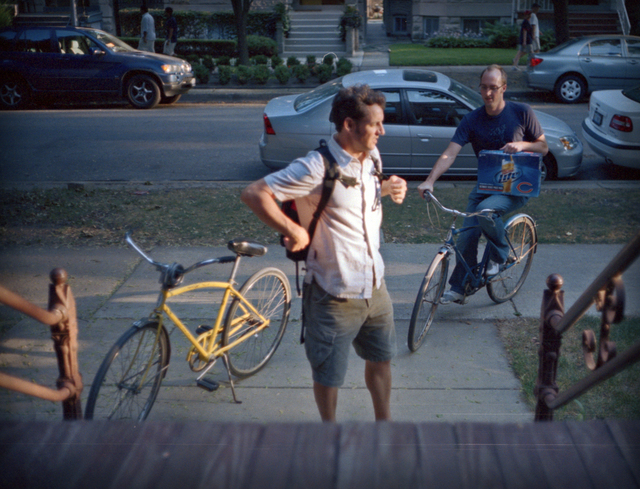What time of day does this scene depict, and what does that suggest about the activities shown? The scene appears to be set in the late afternoon, judging by the soft, warm lighting and the long shadows cast on the road. This timing, along with the relaxed demeanor of the individuals, suggests casual, leisurely activities likely winding down the day's routine or enjoying a calm afternoon outdoors. 